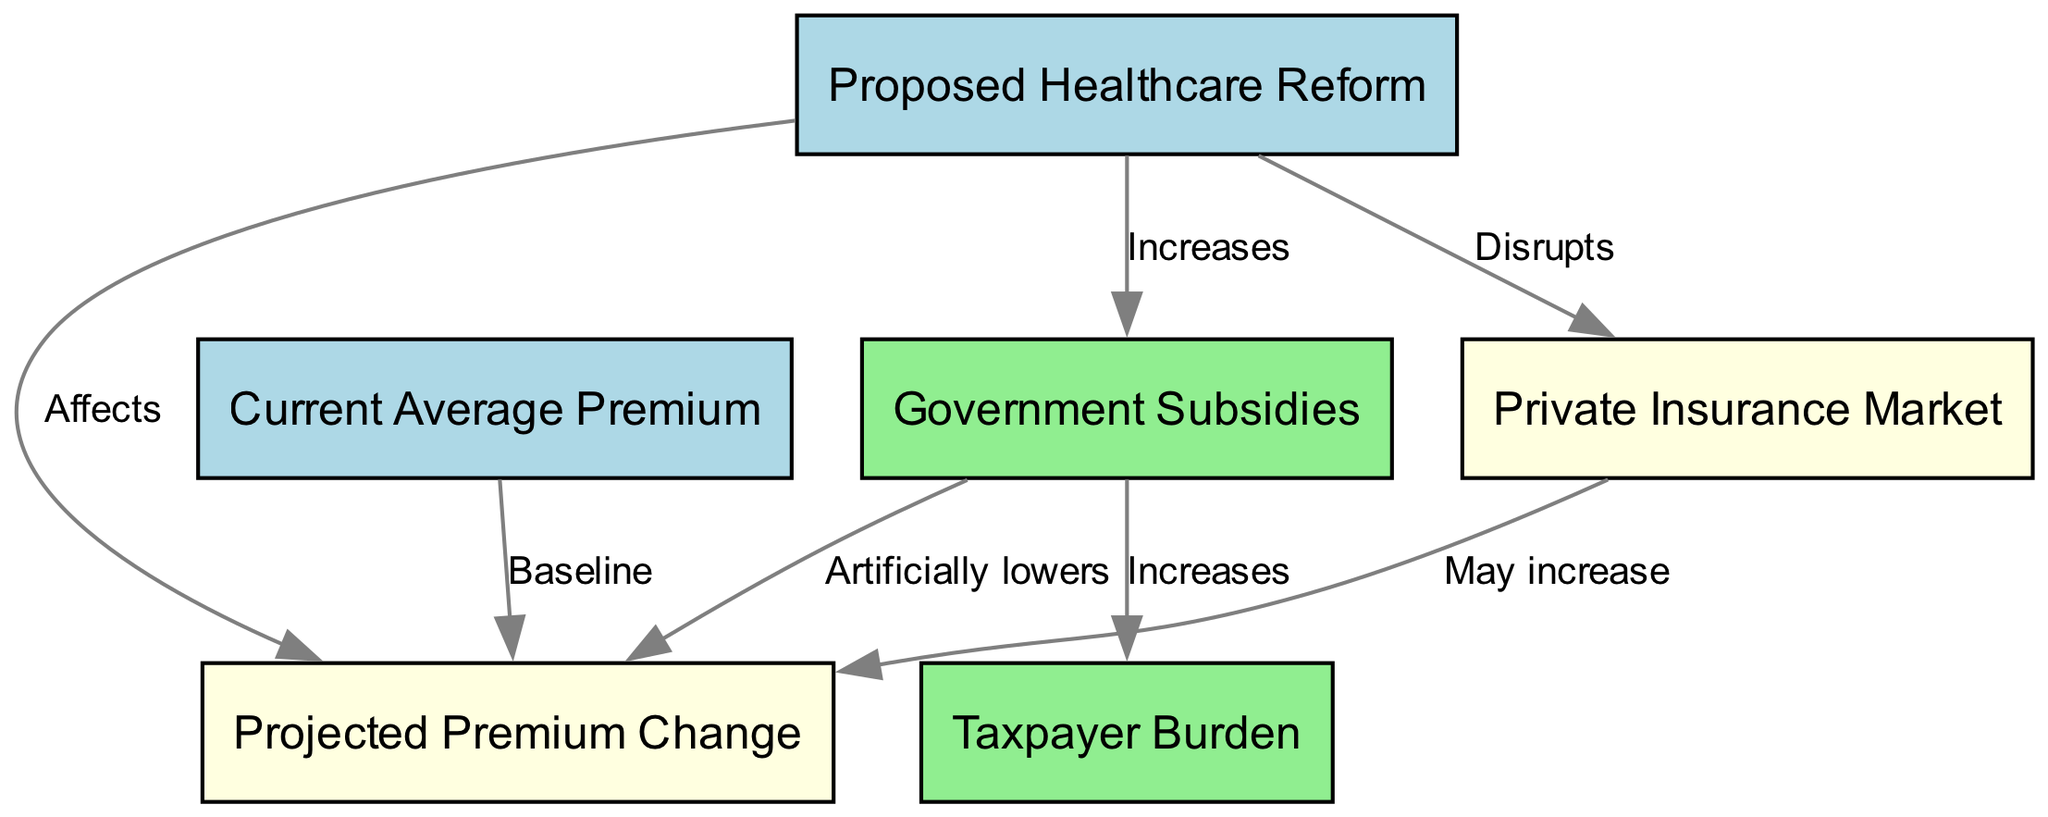What is the current average premium? The diagram shows a node labeled "Current Average Premium" which can be identified directly without any connections or alterations.
Answer: Current Average Premium What do government subsidies do to projected premium change? The edge labeled "Artificially lowers" connects "Government Subsidies" to "Projected Premium Change", indicating that subsidies have a direct effect by decreasing projected premiums.
Answer: Artificially lowers How many nodes are in the diagram? By counting the listed nodes, we find six distinct nodes represented in the diagram, each with a unique label.
Answer: 6 What effect does the proposed healthcare reform have on the private insurance market? The diagram indicates through the edge labeled "Disrupts" that the proposed reform directly impacts the private insurance market.
Answer: Disrupts What increases due to government subsidies? The edge connecting "Government Subsidies" to "Taxpayer Burden" is labeled "Increases", which explicitly states the effect of subsidies on the taxpayer burden.
Answer: Increases How many edges are included in the diagram? Counting the lines connecting nodes shows a total of six edges, each with an individual label describing the relationship.
Answer: 6 What happens to the projected premium change due to the proposed healthcare reform? The edge labeled "Affects" connects "Proposed Healthcare Reform" to "Projected Premium Change", signifying a direct influence on the premiums.
Answer: Affects What is the relationship between government subsidies and taxpayer burden? The edge connecting "Government Subsidies" to "Taxpayer Burden" states that there is an increase in burden, showing a direct relationship based on the diagram.
Answer: Increases What effect may the private insurance market have on projected premium change? The edge from "Private Insurance Market" to "Projected Premium Change" states "May increase", indicating a potential rise in premiums due to market factors.
Answer: May increase 